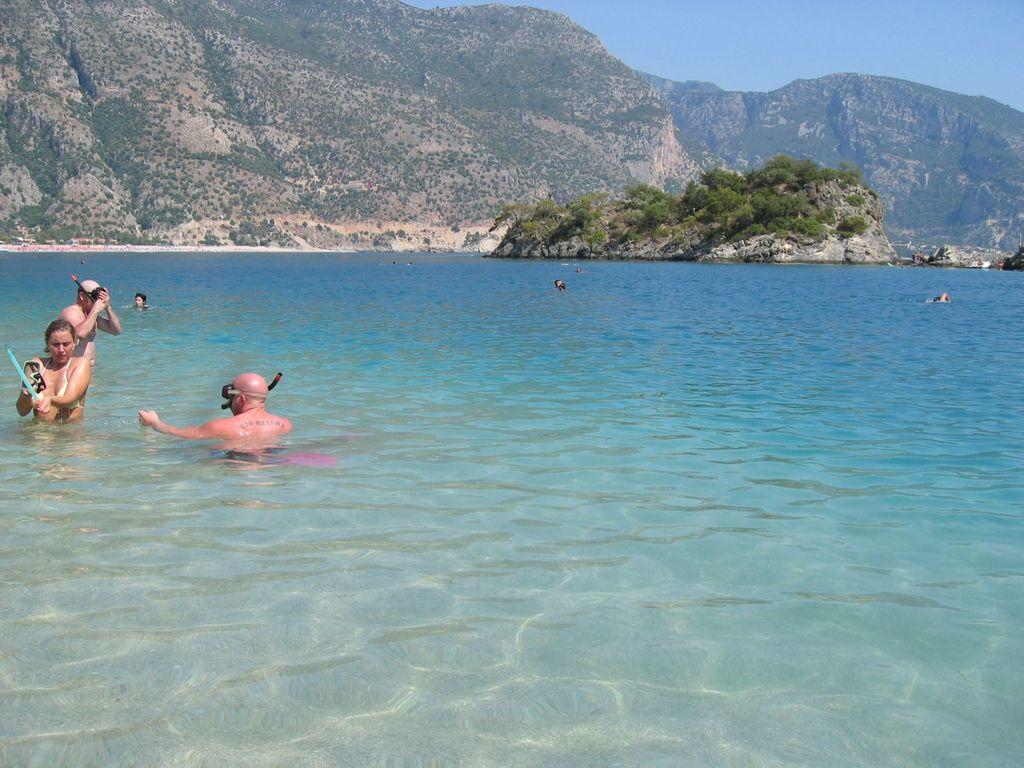What type of natural formation can be seen in the image? There are mountains in the image. What body of water is present in the image? There is sea water in the image. What activity are the people engaged in within the image? There are people diving in the image. What type of jeans are the people wearing while diving in the image? There is no mention of jeans in the image, as the focus is on the sea water, mountains, and people diving. How much money can be seen floating in the sea water in the image? There is no mention of money in the image; the focus is on the sea water, mountains, and people diving. 